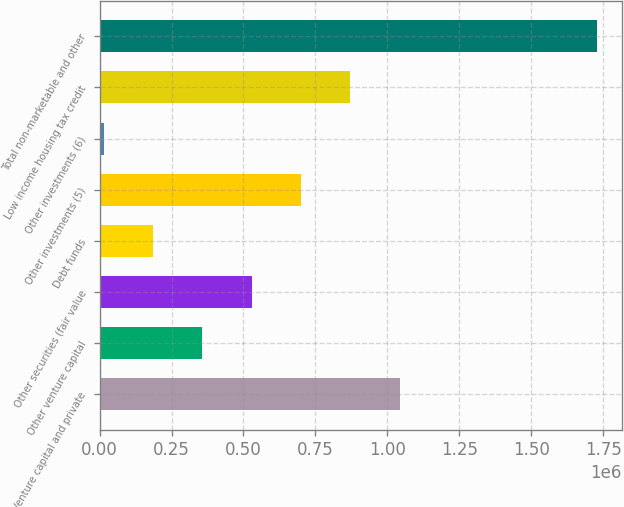<chart> <loc_0><loc_0><loc_500><loc_500><bar_chart><fcel>Venture capital and private<fcel>Other venture capital<fcel>Other securities (fair value<fcel>Debt funds<fcel>Other investments (5)<fcel>Other investments (6)<fcel>Low income housing tax credit<fcel>Total non-marketable and other<nl><fcel>1.04225e+06<fcel>356366<fcel>527838<fcel>184895<fcel>699310<fcel>13423<fcel>870782<fcel>1.72814e+06<nl></chart> 